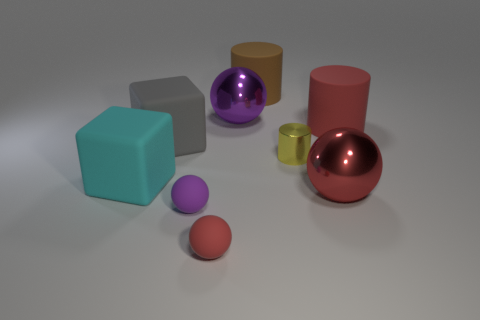What is the color of the other small object that is the same shape as the tiny red rubber object?
Give a very brief answer. Purple. There is a big metallic object on the right side of the brown cylinder; is there a large thing that is on the right side of it?
Make the answer very short. Yes. The cyan rubber block is what size?
Give a very brief answer. Large. What shape is the red thing that is both to the right of the big purple metal ball and in front of the large cyan cube?
Offer a terse response. Sphere. What number of yellow objects are big balls or tiny matte balls?
Your answer should be compact. 0. Is the size of the cube that is to the right of the cyan block the same as the red matte thing that is in front of the big cyan matte object?
Your answer should be compact. No. What number of things are either gray matte things or large yellow cylinders?
Your response must be concise. 1. Are there any big red rubber objects of the same shape as the big cyan object?
Your answer should be compact. No. Are there fewer large red rubber cylinders than green cubes?
Make the answer very short. No. Is the big gray object the same shape as the yellow object?
Your answer should be compact. No. 